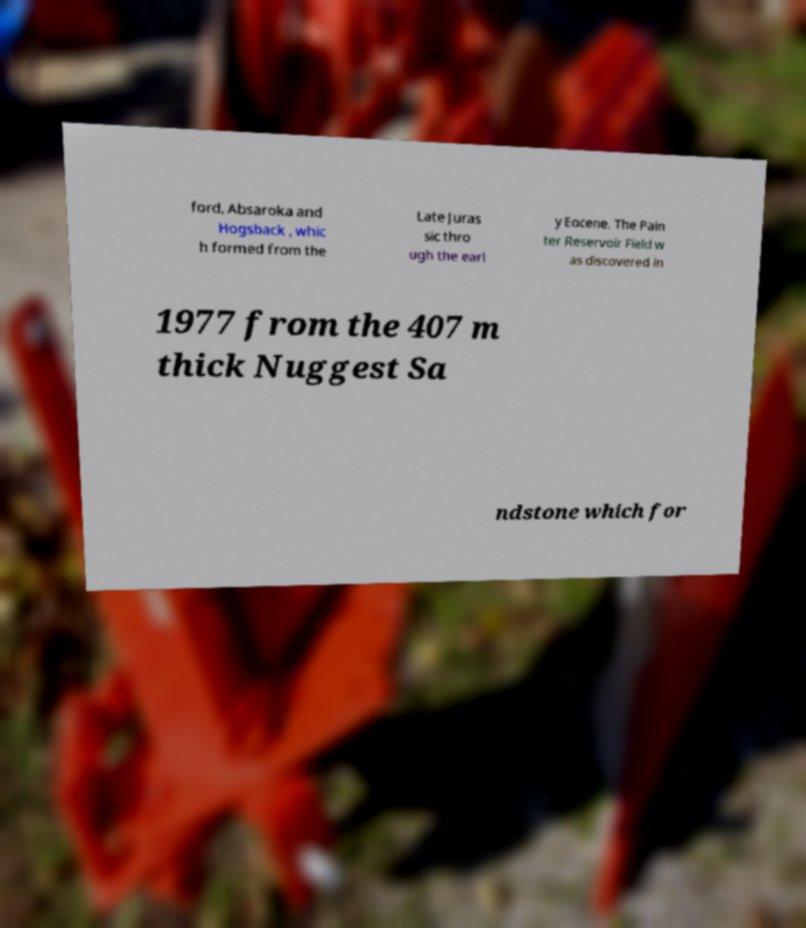Could you extract and type out the text from this image? ford, Absaroka and Hogsback , whic h formed from the Late Juras sic thro ugh the earl y Eocene. The Pain ter Reservoir Field w as discovered in 1977 from the 407 m thick Nuggest Sa ndstone which for 